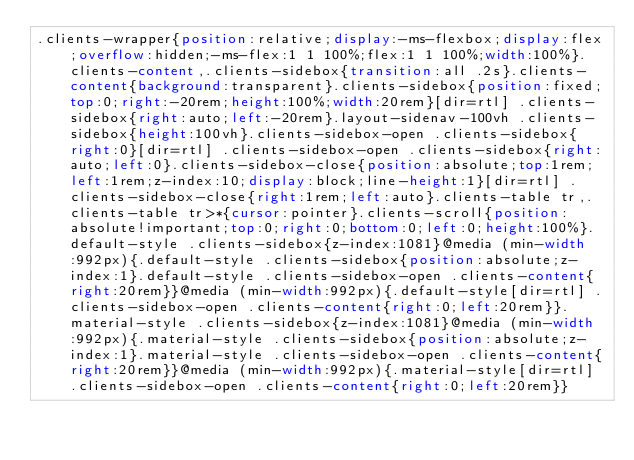<code> <loc_0><loc_0><loc_500><loc_500><_CSS_>.clients-wrapper{position:relative;display:-ms-flexbox;display:flex;overflow:hidden;-ms-flex:1 1 100%;flex:1 1 100%;width:100%}.clients-content,.clients-sidebox{transition:all .2s}.clients-content{background:transparent}.clients-sidebox{position:fixed;top:0;right:-20rem;height:100%;width:20rem}[dir=rtl] .clients-sidebox{right:auto;left:-20rem}.layout-sidenav-100vh .clients-sidebox{height:100vh}.clients-sidebox-open .clients-sidebox{right:0}[dir=rtl] .clients-sidebox-open .clients-sidebox{right:auto;left:0}.clients-sidebox-close{position:absolute;top:1rem;left:1rem;z-index:10;display:block;line-height:1}[dir=rtl] .clients-sidebox-close{right:1rem;left:auto}.clients-table tr,.clients-table tr>*{cursor:pointer}.clients-scroll{position:absolute!important;top:0;right:0;bottom:0;left:0;height:100%}.default-style .clients-sidebox{z-index:1081}@media (min-width:992px){.default-style .clients-sidebox{position:absolute;z-index:1}.default-style .clients-sidebox-open .clients-content{right:20rem}}@media (min-width:992px){.default-style[dir=rtl] .clients-sidebox-open .clients-content{right:0;left:20rem}}.material-style .clients-sidebox{z-index:1081}@media (min-width:992px){.material-style .clients-sidebox{position:absolute;z-index:1}.material-style .clients-sidebox-open .clients-content{right:20rem}}@media (min-width:992px){.material-style[dir=rtl] .clients-sidebox-open .clients-content{right:0;left:20rem}}</code> 